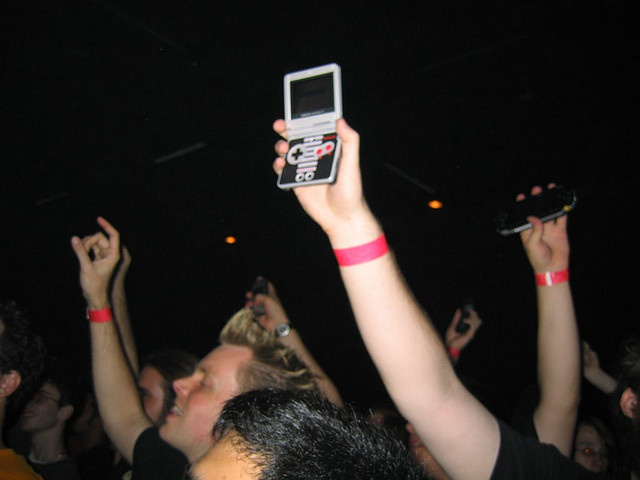Describe the objects in this image and their specific colors. I can see people in black, lightgray, tan, and darkgray tones, people in black, gray, and maroon tones, people in black, gray, and tan tones, people in black and gray tones, and cell phone in black, lightgray, darkgray, and gray tones in this image. 